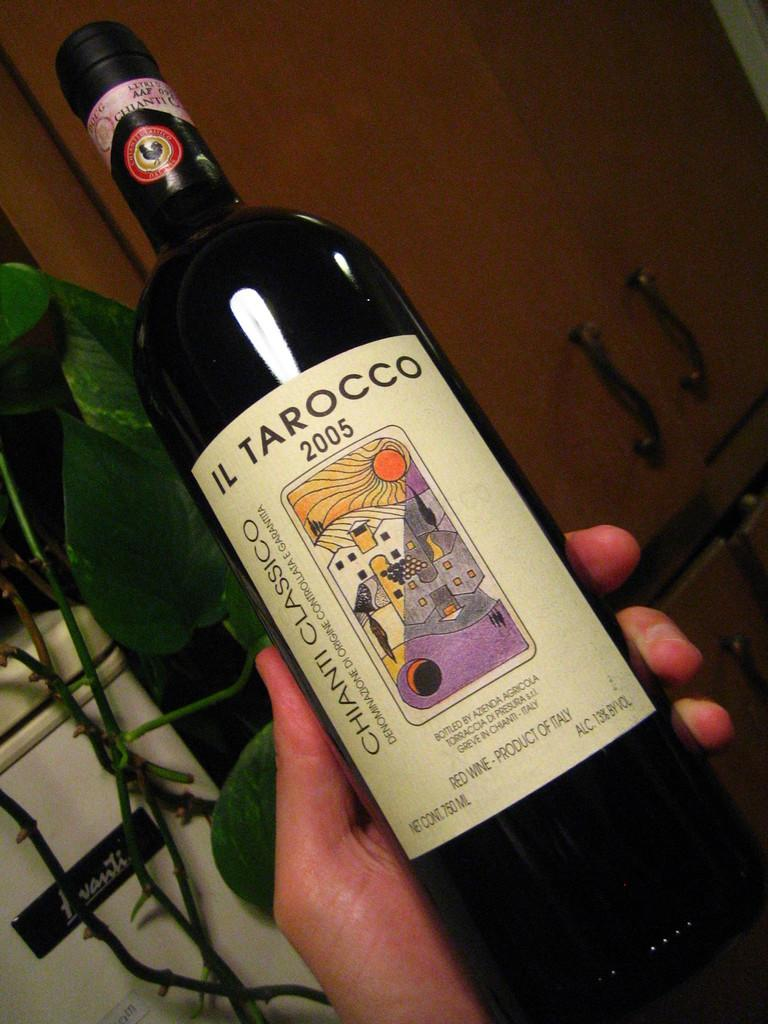<image>
Write a terse but informative summary of the picture. A bottle of Il Tarocco from 2005 has a brightly colored label. 